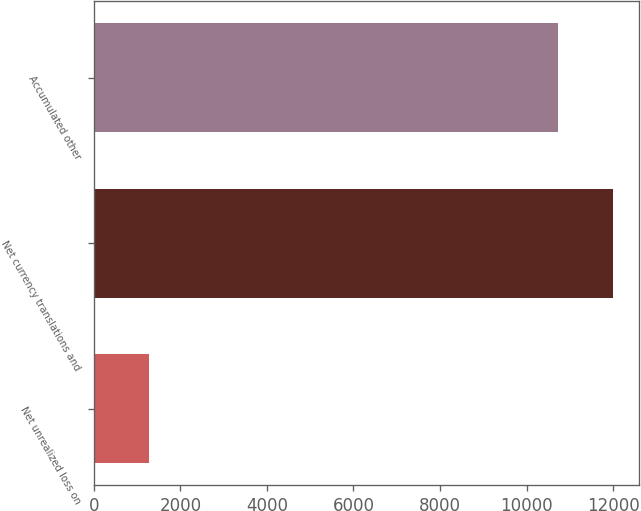Convert chart to OTSL. <chart><loc_0><loc_0><loc_500><loc_500><bar_chart><fcel>Net unrealized loss on<fcel>Net currency translations and<fcel>Accumulated other<nl><fcel>1276<fcel>12002<fcel>10726<nl></chart> 